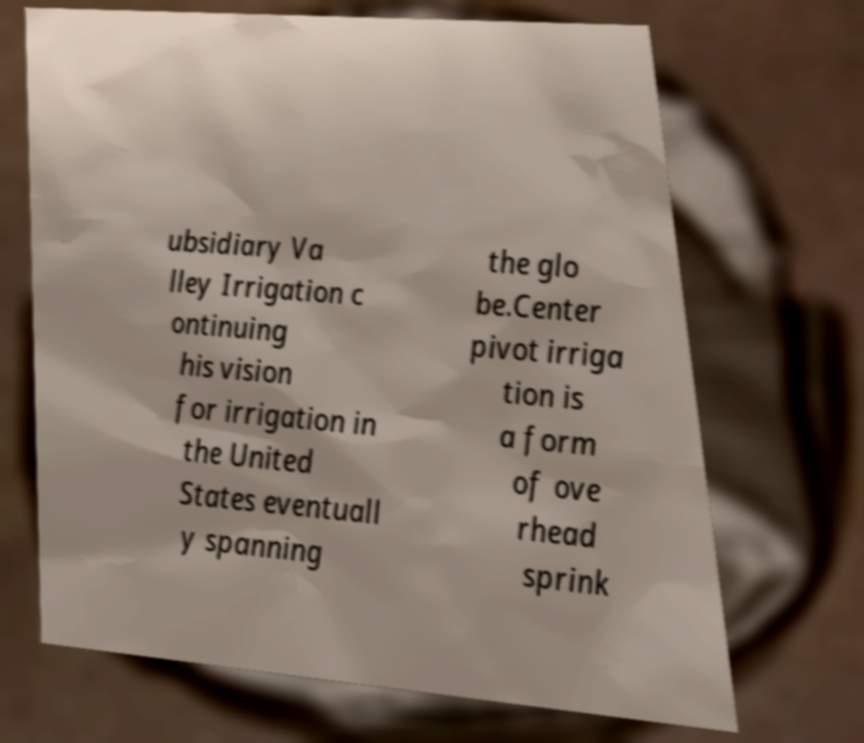Can you read and provide the text displayed in the image?This photo seems to have some interesting text. Can you extract and type it out for me? ubsidiary Va lley Irrigation c ontinuing his vision for irrigation in the United States eventuall y spanning the glo be.Center pivot irriga tion is a form of ove rhead sprink 